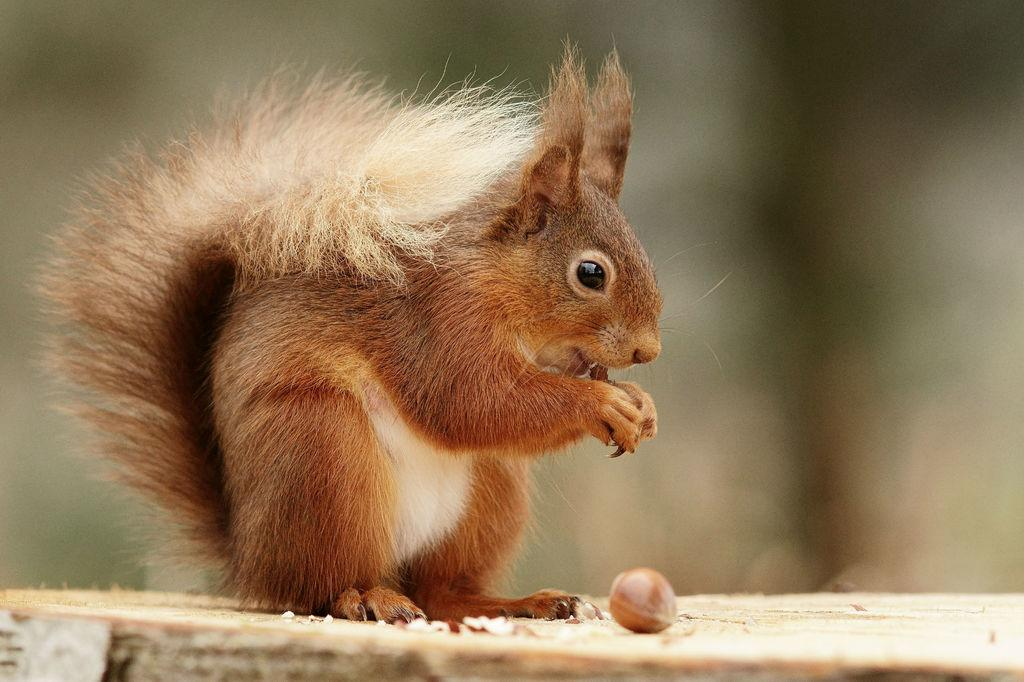What type of surface is visible in the image? There is a wooden surface in the image. What object can be seen on the wooden surface? There is a nut on the wooden surface. What animal is present on the wooden surface? There is a squirrel on the wooden surface. How would you describe the background of the image? The background of the image is blurred. What type of band is playing in the background of the image? There is no band present in the image; the background is blurred. 